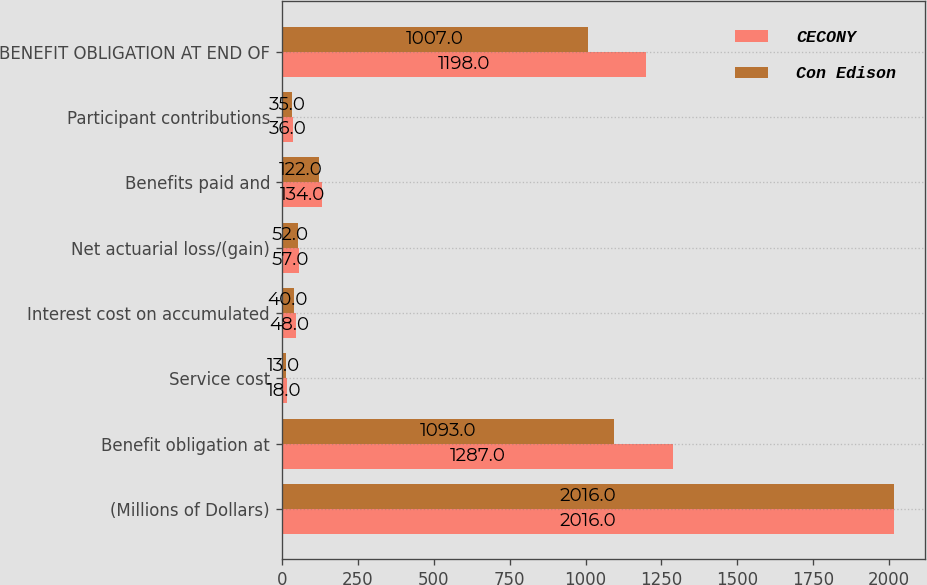Convert chart. <chart><loc_0><loc_0><loc_500><loc_500><stacked_bar_chart><ecel><fcel>(Millions of Dollars)<fcel>Benefit obligation at<fcel>Service cost<fcel>Interest cost on accumulated<fcel>Net actuarial loss/(gain)<fcel>Benefits paid and<fcel>Participant contributions<fcel>BENEFIT OBLIGATION AT END OF<nl><fcel>CECONY<fcel>2016<fcel>1287<fcel>18<fcel>48<fcel>57<fcel>134<fcel>36<fcel>1198<nl><fcel>Con Edison<fcel>2016<fcel>1093<fcel>13<fcel>40<fcel>52<fcel>122<fcel>35<fcel>1007<nl></chart> 